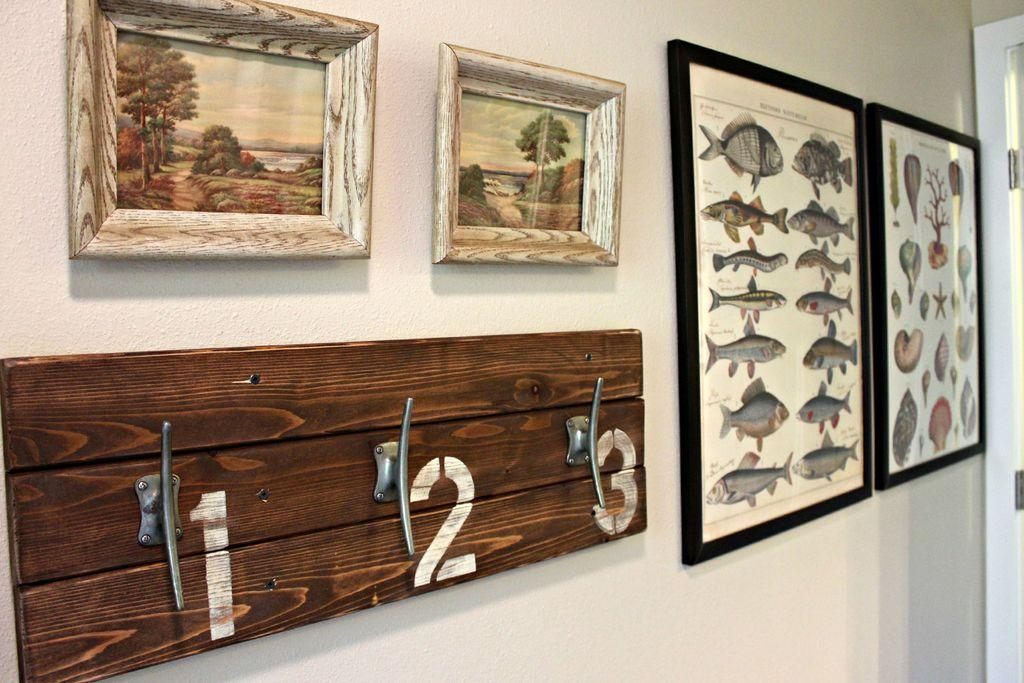What objects are present in the image that are related to displaying photos? There are photo frames in the image. What architectural feature can be seen on the right side of the image? There is a door on the right side of the image. What type of exchange is taking place between the people in the image? There are no people present in the image, so it is not possible to determine if an exchange is taking place. 